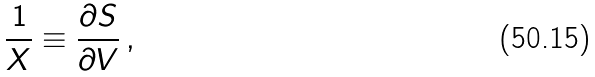<formula> <loc_0><loc_0><loc_500><loc_500>\frac { 1 } { X } \equiv \frac { \partial S } { \partial V } \, ,</formula> 